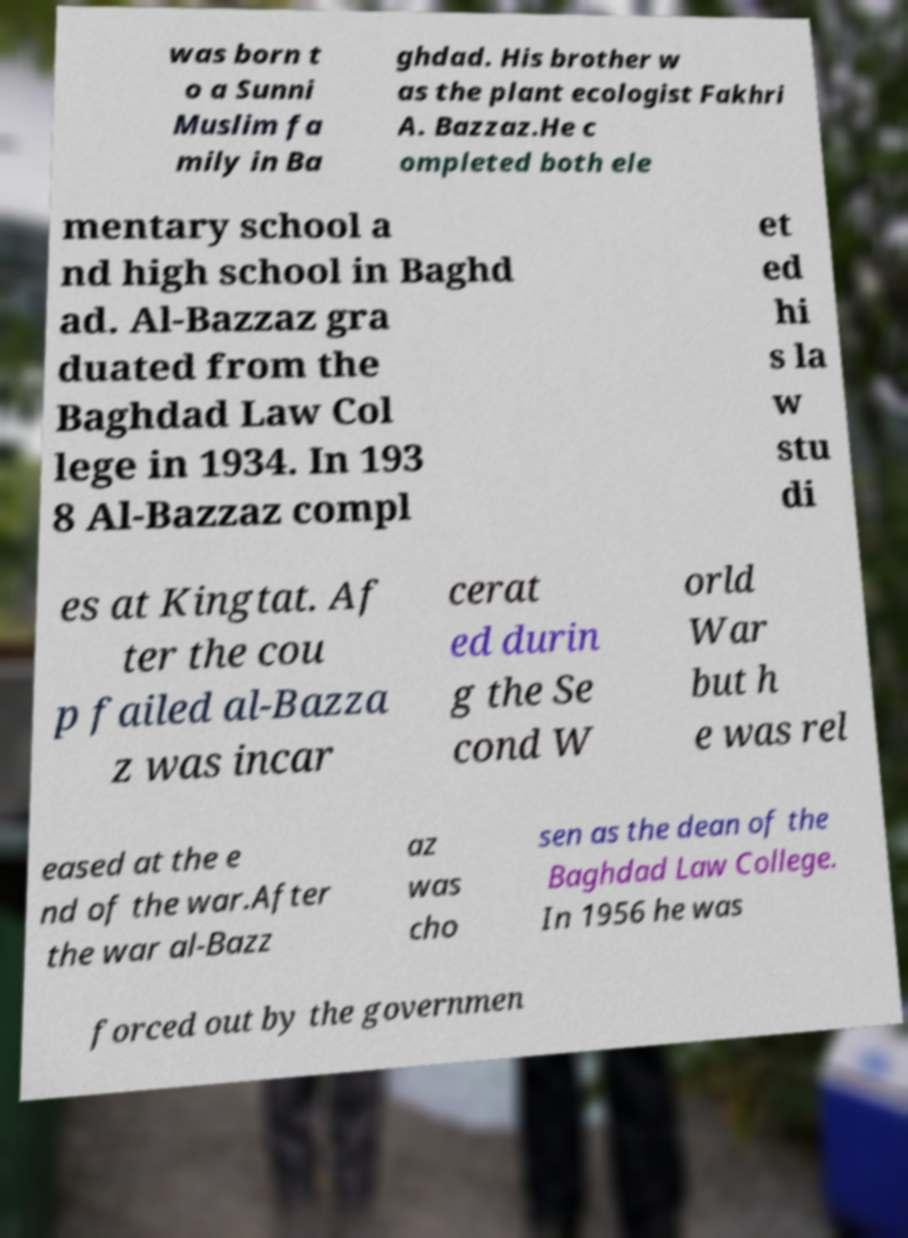Could you assist in decoding the text presented in this image and type it out clearly? was born t o a Sunni Muslim fa mily in Ba ghdad. His brother w as the plant ecologist Fakhri A. Bazzaz.He c ompleted both ele mentary school a nd high school in Baghd ad. Al-Bazzaz gra duated from the Baghdad Law Col lege in 1934. In 193 8 Al-Bazzaz compl et ed hi s la w stu di es at Kingtat. Af ter the cou p failed al-Bazza z was incar cerat ed durin g the Se cond W orld War but h e was rel eased at the e nd of the war.After the war al-Bazz az was cho sen as the dean of the Baghdad Law College. In 1956 he was forced out by the governmen 